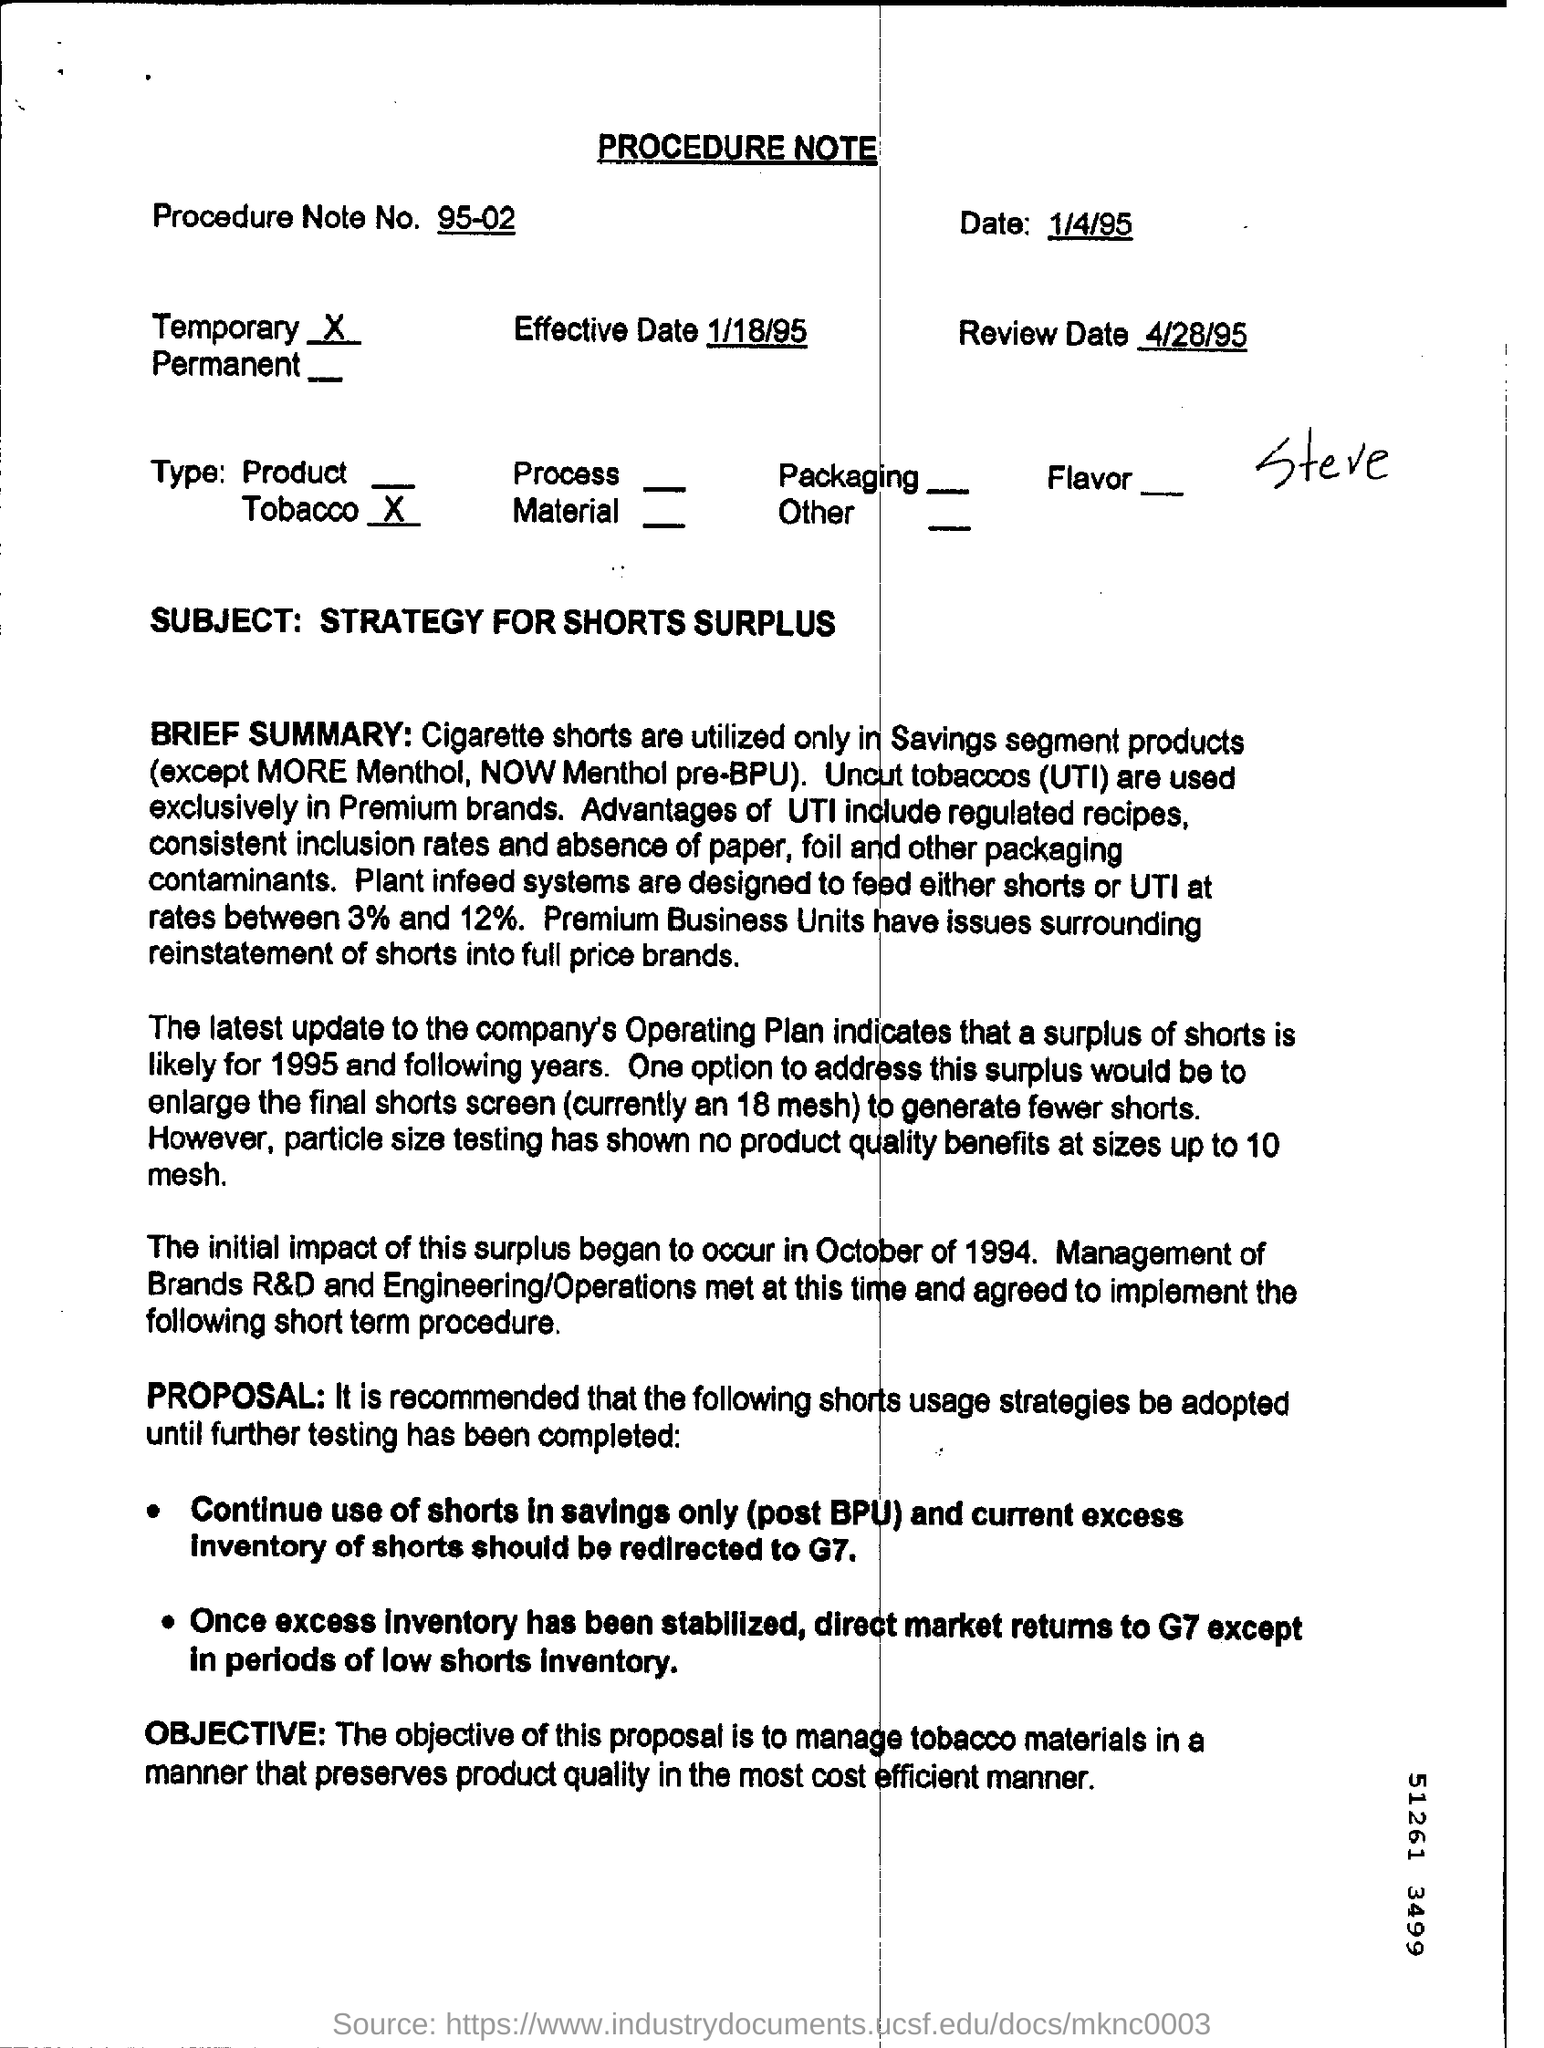Can you tell me the effective date mentioned in the document? The effective date mentioned in the document is 1/18/95. 